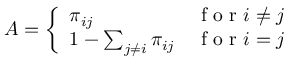Convert formula to latex. <formula><loc_0><loc_0><loc_500><loc_500>A = \left \{ \begin{array} { l l } { \pi _ { i j } } & { f o r i \neq j } \\ { 1 - \sum _ { j \neq i } \pi _ { i j } } & { f o r i = j } \end{array}</formula> 